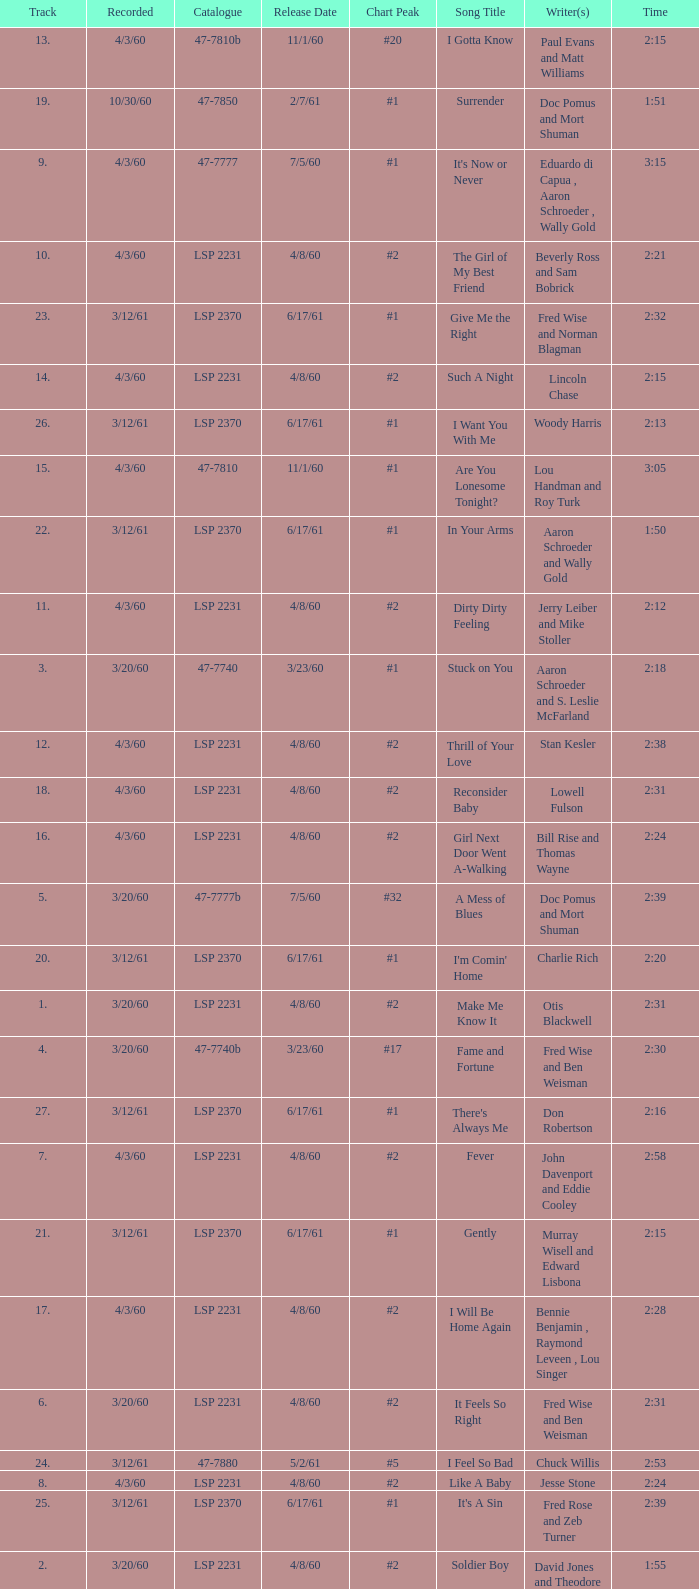On songs with track numbers smaller than number 17 and catalogues of LSP 2231, who are the writer(s)? Otis Blackwell, David Jones and Theodore Williams Jr., Fred Wise and Ben Weisman, John Davenport and Eddie Cooley, Jesse Stone, Beverly Ross and Sam Bobrick, Jerry Leiber and Mike Stoller, Stan Kesler, Lincoln Chase, Bill Rise and Thomas Wayne. 